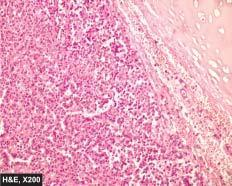what shows a characteristic nested of cells separated by fibrovascular septa?
Answer the question using a single word or phrase. Tumour 